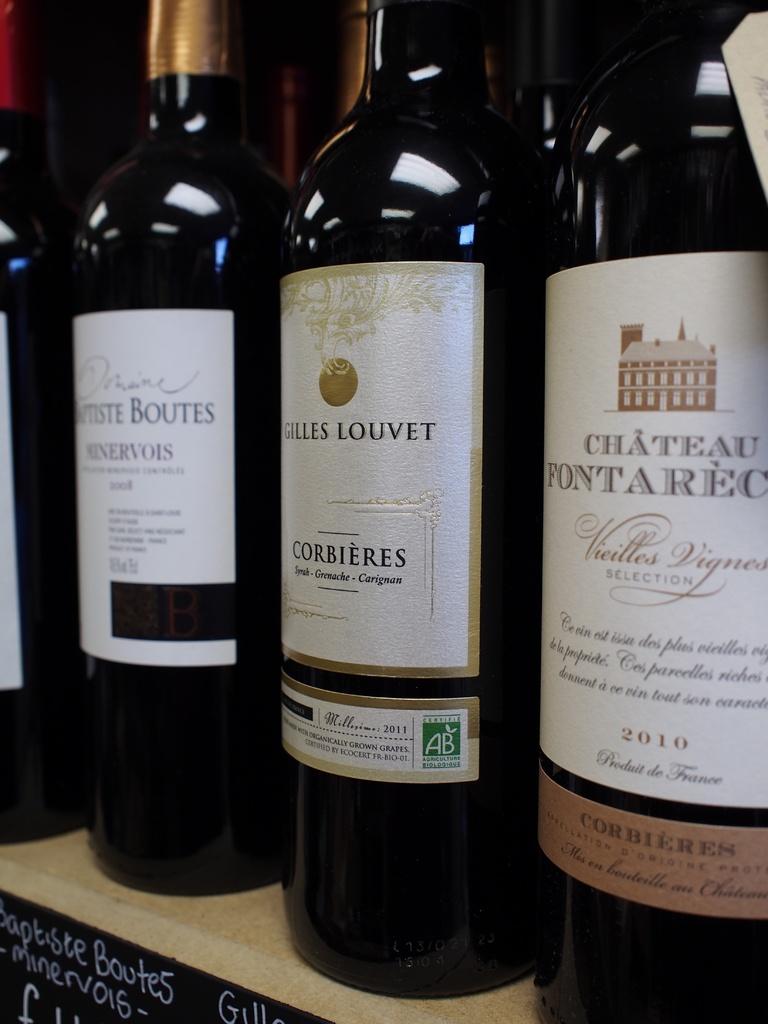What is the brand of the wine on the right?
Provide a short and direct response. Chateau fontarec. 